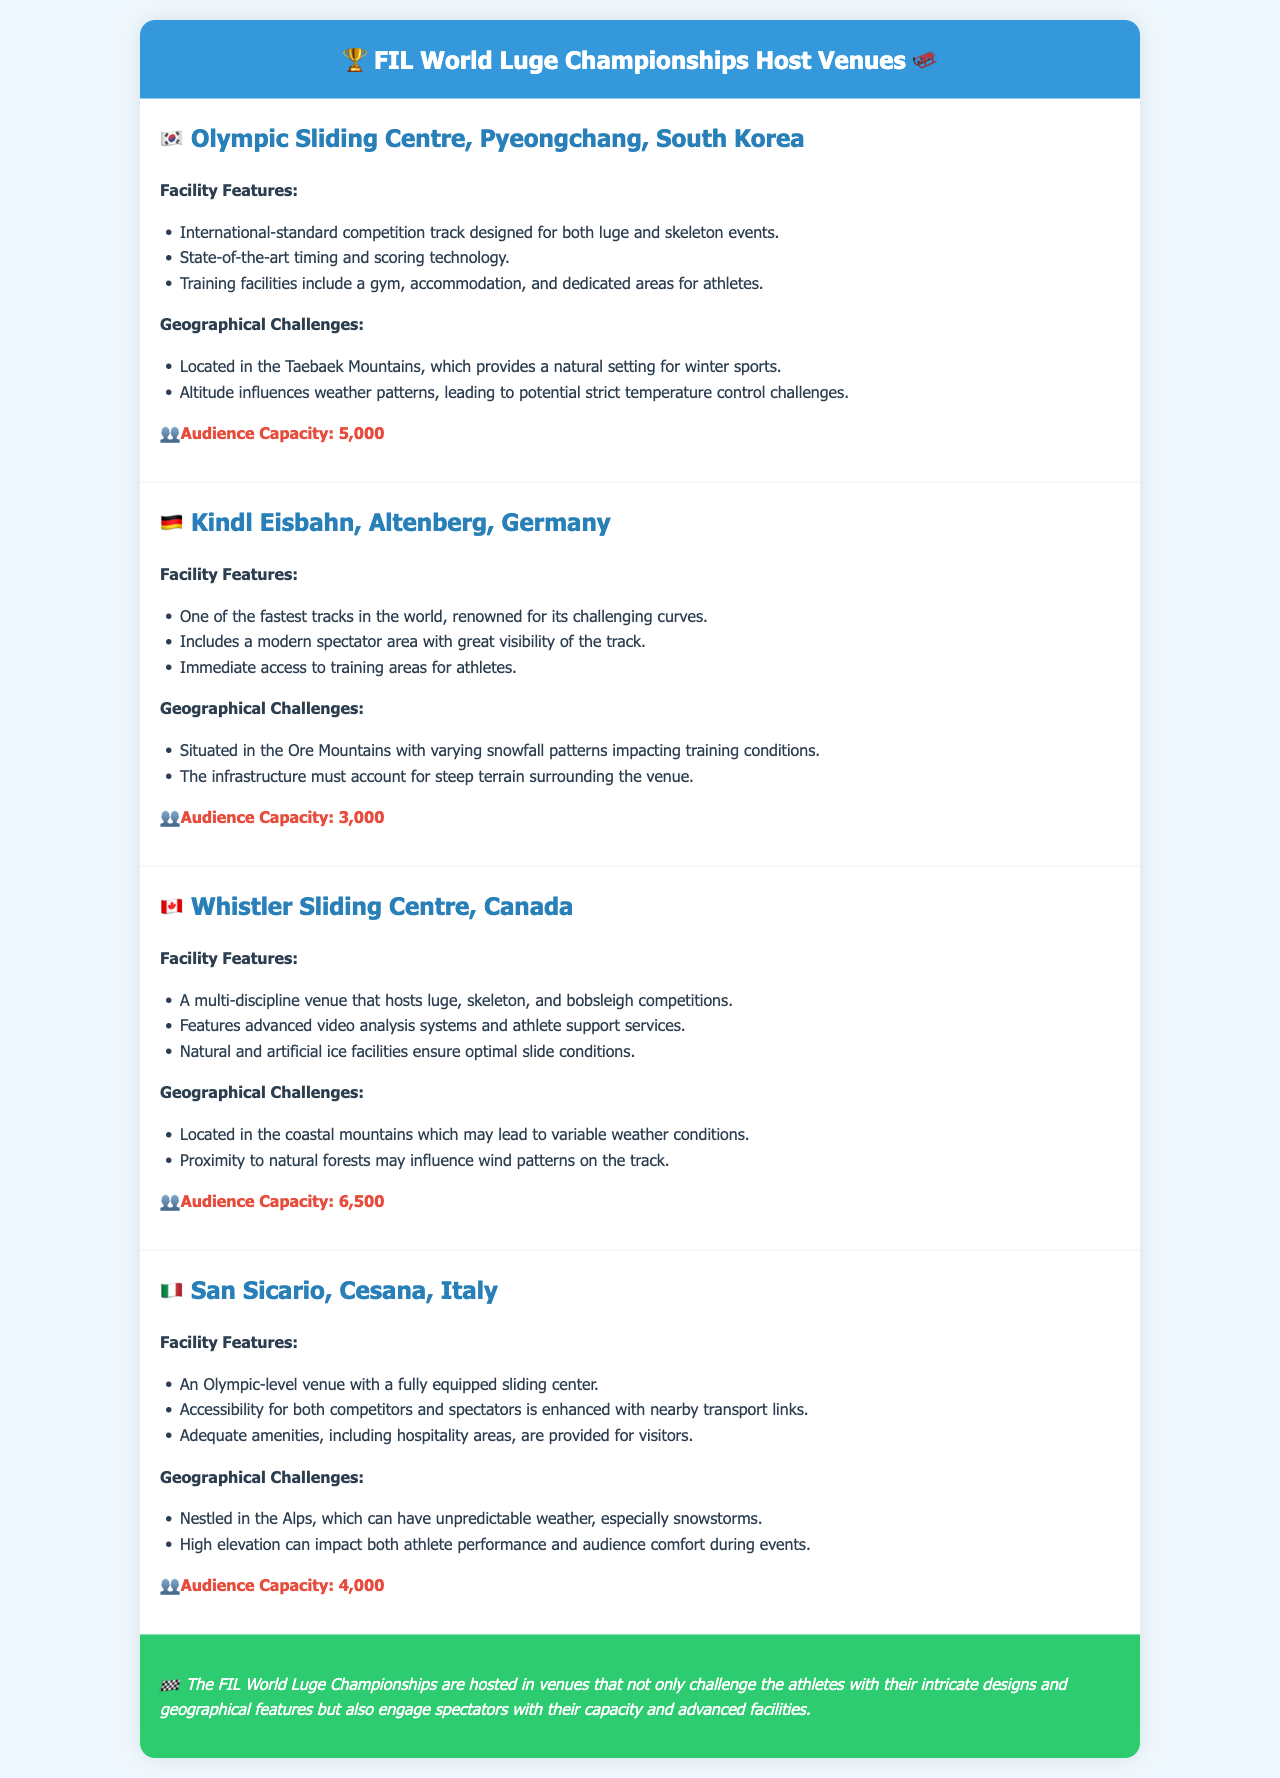What is the audience capacity of the Olympic Sliding Centre? The audience capacity of the Olympic Sliding Centre is provided in the document.
Answer: 5,000 Which country hosts the Kindl Eisbahn venue? The document explicitly states the country associated with the Kindl Eisbahn venue.
Answer: Germany What geographical challenge is mentioned for the Whistler Sliding Centre? The document describes geographical challenges faced by venues, specifically for the Whistler Sliding Centre.
Answer: Variable weather conditions How many venues are listed in the report? The total number of venues can be counted from the document.
Answer: 4 What type of sliding events does the San Sicario venue support? The document outlines the types of sliding competitions each venue can host, particularly for San Sicario.
Answer: Olympic-level What is a feature of the Kindl Eisbahn spectator area? There are specific descriptions about the spectator area in the document relating to the Kindl Eisbahn.
Answer: Great visibility of the track What natural feature influences wind patterns at the Whistler Sliding Centre? The document identifies a natural feature that affects wind patterns at this venue.
Answer: Natural forests What technology is highlighted at the Olympic Sliding Centre? The document mentions specific technologies used at venues, particularly at the Olympic Sliding Centre.
Answer: Timing and scoring technology 